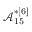Convert formula to latex. <formula><loc_0><loc_0><loc_500><loc_500>\mathcal { A } _ { 1 5 } ^ { * [ 6 ] }</formula> 